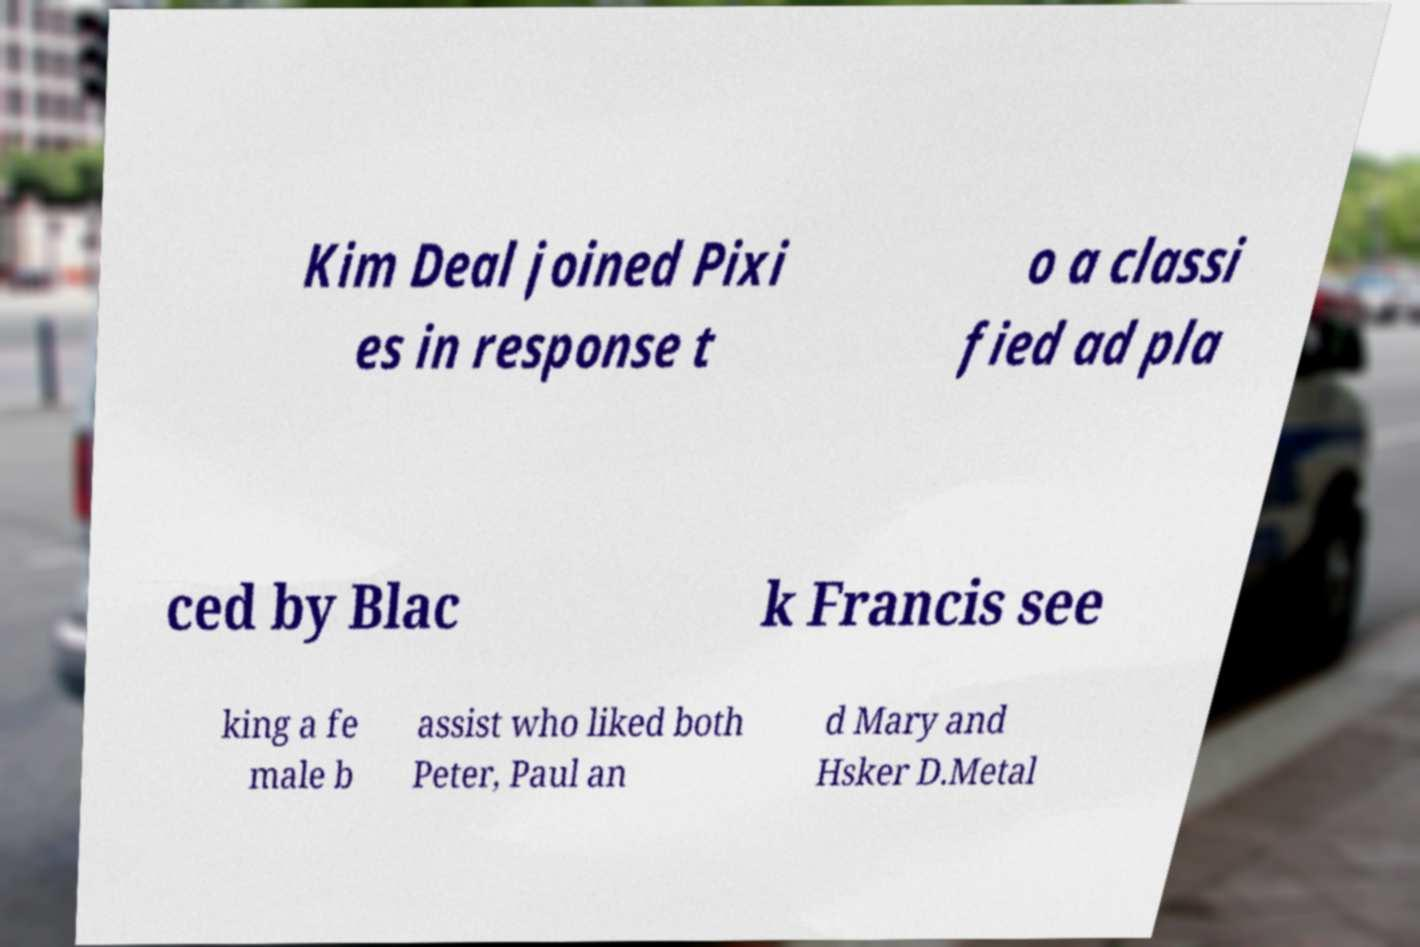Can you accurately transcribe the text from the provided image for me? Kim Deal joined Pixi es in response t o a classi fied ad pla ced by Blac k Francis see king a fe male b assist who liked both Peter, Paul an d Mary and Hsker D.Metal 